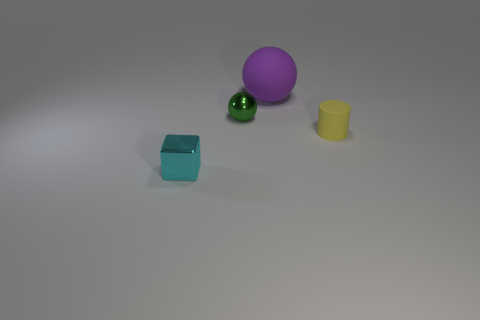Add 2 matte objects. How many objects exist? 6 Subtract all cubes. How many objects are left? 3 Subtract 0 green cylinders. How many objects are left? 4 Subtract all small yellow cylinders. Subtract all large purple spheres. How many objects are left? 2 Add 1 purple things. How many purple things are left? 2 Add 2 big purple things. How many big purple things exist? 3 